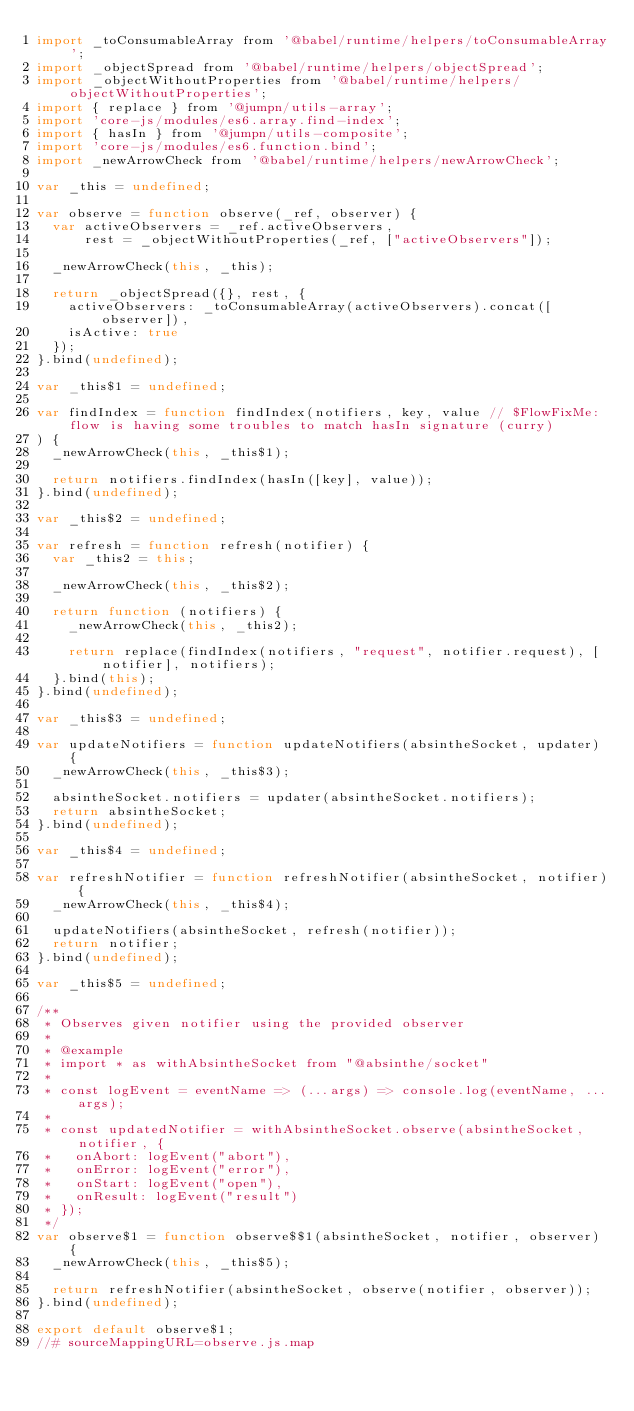<code> <loc_0><loc_0><loc_500><loc_500><_JavaScript_>import _toConsumableArray from '@babel/runtime/helpers/toConsumableArray';
import _objectSpread from '@babel/runtime/helpers/objectSpread';
import _objectWithoutProperties from '@babel/runtime/helpers/objectWithoutProperties';
import { replace } from '@jumpn/utils-array';
import 'core-js/modules/es6.array.find-index';
import { hasIn } from '@jumpn/utils-composite';
import 'core-js/modules/es6.function.bind';
import _newArrowCheck from '@babel/runtime/helpers/newArrowCheck';

var _this = undefined;

var observe = function observe(_ref, observer) {
  var activeObservers = _ref.activeObservers,
      rest = _objectWithoutProperties(_ref, ["activeObservers"]);

  _newArrowCheck(this, _this);

  return _objectSpread({}, rest, {
    activeObservers: _toConsumableArray(activeObservers).concat([observer]),
    isActive: true
  });
}.bind(undefined);

var _this$1 = undefined;

var findIndex = function findIndex(notifiers, key, value // $FlowFixMe: flow is having some troubles to match hasIn signature (curry)
) {
  _newArrowCheck(this, _this$1);

  return notifiers.findIndex(hasIn([key], value));
}.bind(undefined);

var _this$2 = undefined;

var refresh = function refresh(notifier) {
  var _this2 = this;

  _newArrowCheck(this, _this$2);

  return function (notifiers) {
    _newArrowCheck(this, _this2);

    return replace(findIndex(notifiers, "request", notifier.request), [notifier], notifiers);
  }.bind(this);
}.bind(undefined);

var _this$3 = undefined;

var updateNotifiers = function updateNotifiers(absintheSocket, updater) {
  _newArrowCheck(this, _this$3);

  absintheSocket.notifiers = updater(absintheSocket.notifiers);
  return absintheSocket;
}.bind(undefined);

var _this$4 = undefined;

var refreshNotifier = function refreshNotifier(absintheSocket, notifier) {
  _newArrowCheck(this, _this$4);

  updateNotifiers(absintheSocket, refresh(notifier));
  return notifier;
}.bind(undefined);

var _this$5 = undefined;

/**
 * Observes given notifier using the provided observer
 *
 * @example
 * import * as withAbsintheSocket from "@absinthe/socket"
 *
 * const logEvent = eventName => (...args) => console.log(eventName, ...args);
 *
 * const updatedNotifier = withAbsintheSocket.observe(absintheSocket, notifier, {
 *   onAbort: logEvent("abort"),
 *   onError: logEvent("error"),
 *   onStart: logEvent("open"),
 *   onResult: logEvent("result")
 * });
 */
var observe$1 = function observe$$1(absintheSocket, notifier, observer) {
  _newArrowCheck(this, _this$5);

  return refreshNotifier(absintheSocket, observe(notifier, observer));
}.bind(undefined);

export default observe$1;
//# sourceMappingURL=observe.js.map
</code> 